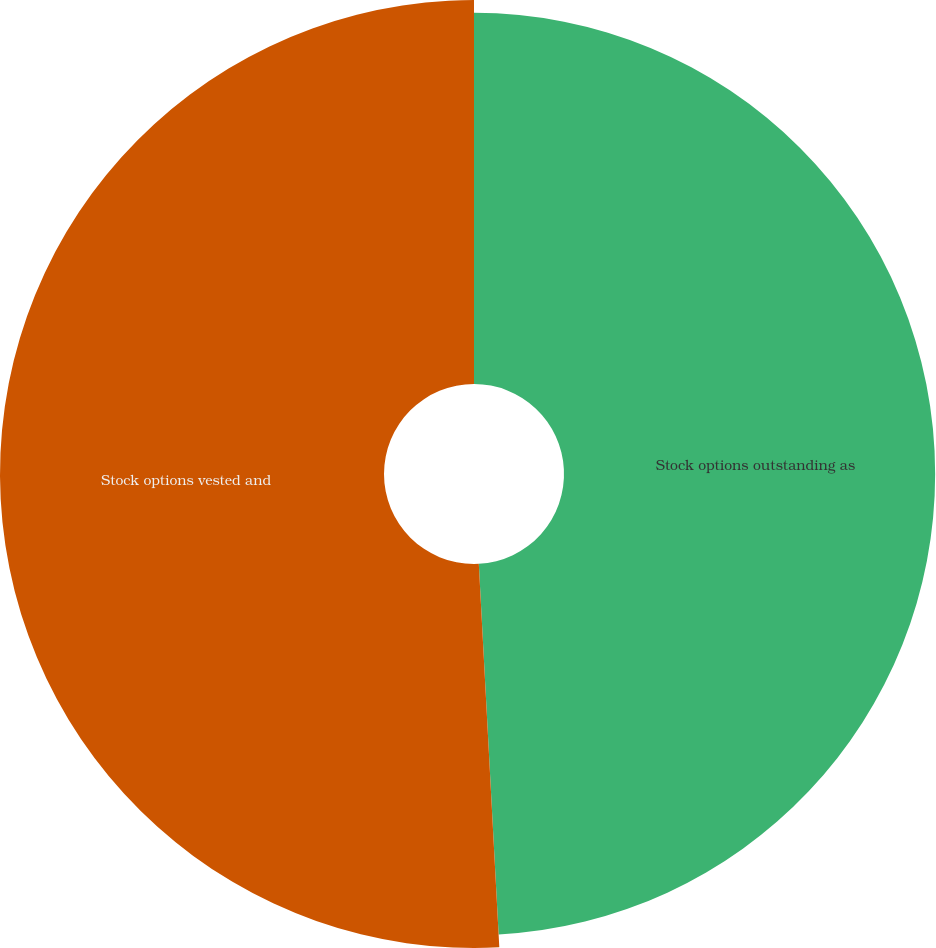Convert chart. <chart><loc_0><loc_0><loc_500><loc_500><pie_chart><fcel>Stock options outstanding as<fcel>Stock options vested and<nl><fcel>49.15%<fcel>50.85%<nl></chart> 